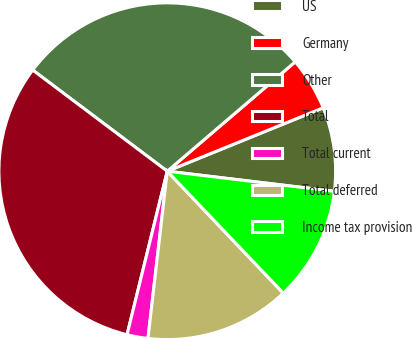Convert chart to OTSL. <chart><loc_0><loc_0><loc_500><loc_500><pie_chart><fcel>US<fcel>Germany<fcel>Other<fcel>Total<fcel>Total current<fcel>Total deferred<fcel>Income tax provision<nl><fcel>8.05%<fcel>5.11%<fcel>28.48%<fcel>31.42%<fcel>2.01%<fcel>13.93%<fcel>10.99%<nl></chart> 